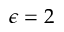<formula> <loc_0><loc_0><loc_500><loc_500>\epsilon = 2</formula> 